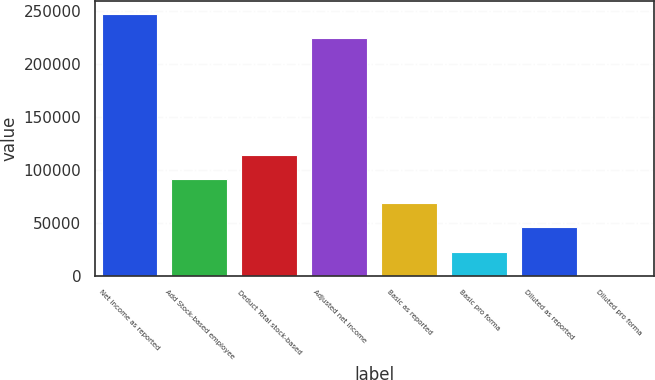<chart> <loc_0><loc_0><loc_500><loc_500><bar_chart><fcel>Net income as reported<fcel>Add Stock-based employee<fcel>Deduct Total stock-based<fcel>Adjusted net income<fcel>Basic as reported<fcel>Basic pro forma<fcel>Diluted as reported<fcel>Diluted pro forma<nl><fcel>246824<fcel>91574.4<fcel>114468<fcel>223931<fcel>68681.2<fcel>22894.6<fcel>45787.9<fcel>1.38<nl></chart> 